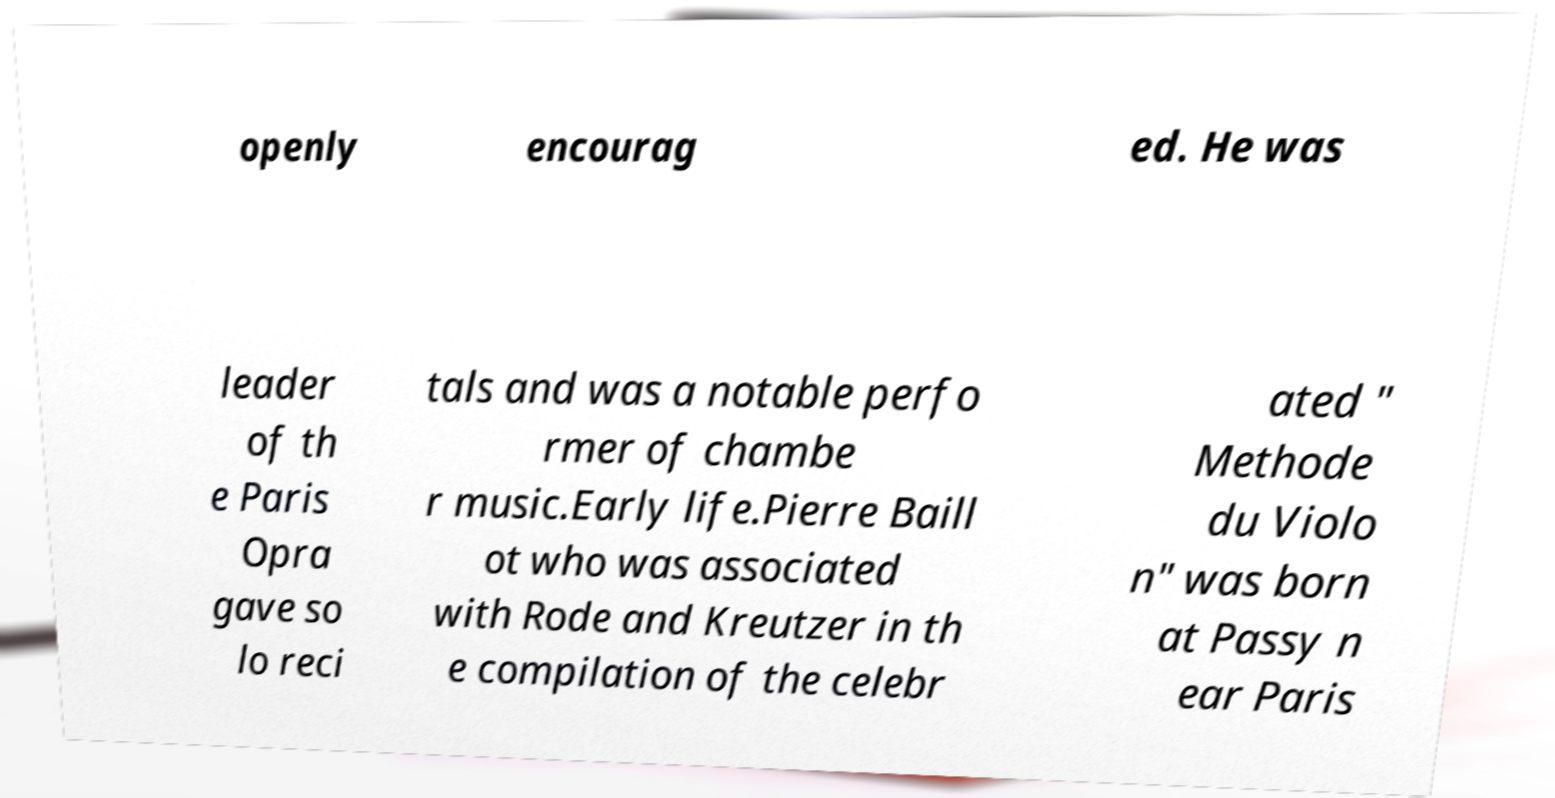Could you assist in decoding the text presented in this image and type it out clearly? openly encourag ed. He was leader of th e Paris Opra gave so lo reci tals and was a notable perfo rmer of chambe r music.Early life.Pierre Baill ot who was associated with Rode and Kreutzer in th e compilation of the celebr ated " Methode du Violo n" was born at Passy n ear Paris 